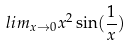Convert formula to latex. <formula><loc_0><loc_0><loc_500><loc_500>l i m _ { x \rightarrow 0 } x ^ { 2 } \sin ( \frac { 1 } { x } )</formula> 